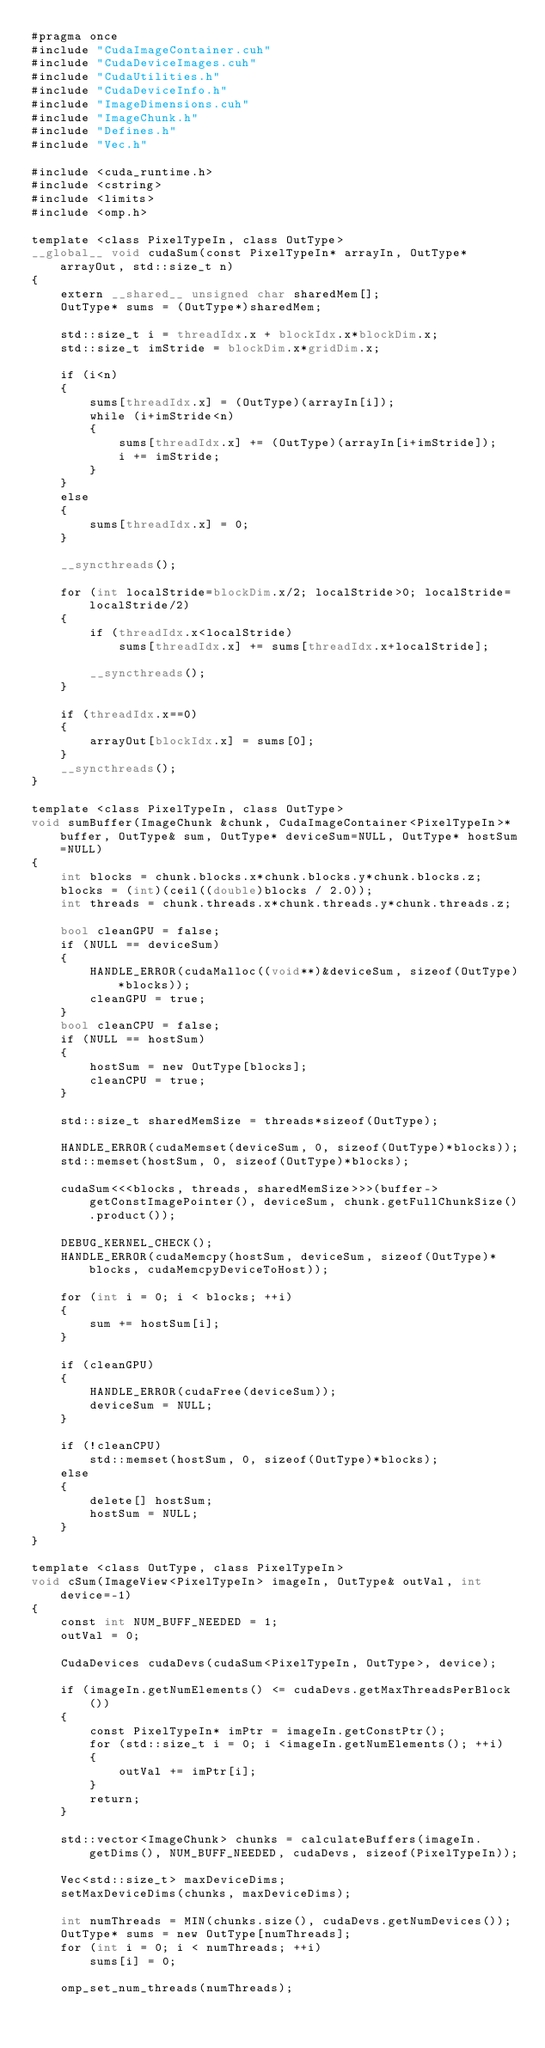Convert code to text. <code><loc_0><loc_0><loc_500><loc_500><_Cuda_>#pragma once
#include "CudaImageContainer.cuh"
#include "CudaDeviceImages.cuh"
#include "CudaUtilities.h"
#include "CudaDeviceInfo.h"
#include "ImageDimensions.cuh"
#include "ImageChunk.h"
#include "Defines.h"
#include "Vec.h"

#include <cuda_runtime.h>
#include <cstring>
#include <limits>
#include <omp.h>

template <class PixelTypeIn, class OutType>
__global__ void cudaSum(const PixelTypeIn* arrayIn, OutType* arrayOut, std::size_t n)
{
	extern __shared__ unsigned char sharedMem[];
	OutType* sums = (OutType*)sharedMem;

	std::size_t i = threadIdx.x + blockIdx.x*blockDim.x;
	std::size_t imStride = blockDim.x*gridDim.x;

	if (i<n)
	{
		sums[threadIdx.x] = (OutType)(arrayIn[i]);
		while (i+imStride<n)
		{
			sums[threadIdx.x] += (OutType)(arrayIn[i+imStride]);
			i += imStride;
		}
	}
	else
	{
		sums[threadIdx.x] = 0;
	}

	__syncthreads();

	for (int localStride=blockDim.x/2; localStride>0; localStride=localStride/2)
	{
		if (threadIdx.x<localStride)
			sums[threadIdx.x] += sums[threadIdx.x+localStride];

		__syncthreads();
	}

	if (threadIdx.x==0)
	{
		arrayOut[blockIdx.x] = sums[0];
	}
	__syncthreads();
}

template <class PixelTypeIn, class OutType>
void sumBuffer(ImageChunk &chunk, CudaImageContainer<PixelTypeIn>* buffer, OutType& sum, OutType* deviceSum=NULL, OutType* hostSum=NULL)
{
	int blocks = chunk.blocks.x*chunk.blocks.y*chunk.blocks.z;
	blocks = (int)(ceil((double)blocks / 2.0));
	int threads = chunk.threads.x*chunk.threads.y*chunk.threads.z;

	bool cleanGPU = false;
	if (NULL == deviceSum)
	{
		HANDLE_ERROR(cudaMalloc((void**)&deviceSum, sizeof(OutType)*blocks));
		cleanGPU = true;
	}
	bool cleanCPU = false;
	if (NULL == hostSum)
	{
		hostSum = new OutType[blocks];
		cleanCPU = true;
	}

	std::size_t sharedMemSize = threads*sizeof(OutType);

	HANDLE_ERROR(cudaMemset(deviceSum, 0, sizeof(OutType)*blocks));
	std::memset(hostSum, 0, sizeof(OutType)*blocks);

	cudaSum<<<blocks, threads, sharedMemSize>>>(buffer->getConstImagePointer(), deviceSum, chunk.getFullChunkSize().product());

	DEBUG_KERNEL_CHECK();
	HANDLE_ERROR(cudaMemcpy(hostSum, deviceSum, sizeof(OutType)*blocks, cudaMemcpyDeviceToHost));

	for (int i = 0; i < blocks; ++i)
	{
		sum += hostSum[i];
	}

	if (cleanGPU)
	{
		HANDLE_ERROR(cudaFree(deviceSum));
		deviceSum = NULL;
	}

	if (!cleanCPU)
		std::memset(hostSum, 0, sizeof(OutType)*blocks);
	else
	{
		delete[] hostSum;
		hostSum = NULL;
	}
}

template <class OutType, class PixelTypeIn>
void cSum(ImageView<PixelTypeIn> imageIn, OutType& outVal, int device=-1)
{
	const int NUM_BUFF_NEEDED = 1;
	outVal = 0;
	
	CudaDevices cudaDevs(cudaSum<PixelTypeIn, OutType>, device);

	if (imageIn.getNumElements() <= cudaDevs.getMaxThreadsPerBlock())
	{
		const PixelTypeIn* imPtr = imageIn.getConstPtr();
		for (std::size_t i = 0; i <imageIn.getNumElements(); ++i)
		{
			outVal += imPtr[i];
		}
		return;
	}

	std::vector<ImageChunk> chunks = calculateBuffers(imageIn.getDims(), NUM_BUFF_NEEDED, cudaDevs, sizeof(PixelTypeIn));

	Vec<std::size_t> maxDeviceDims;
	setMaxDeviceDims(chunks, maxDeviceDims);

	int numThreads = MIN(chunks.size(), cudaDevs.getNumDevices());
	OutType* sums = new OutType[numThreads];
	for (int i = 0; i < numThreads; ++i)
		sums[i] = 0;

	omp_set_num_threads(numThreads);</code> 